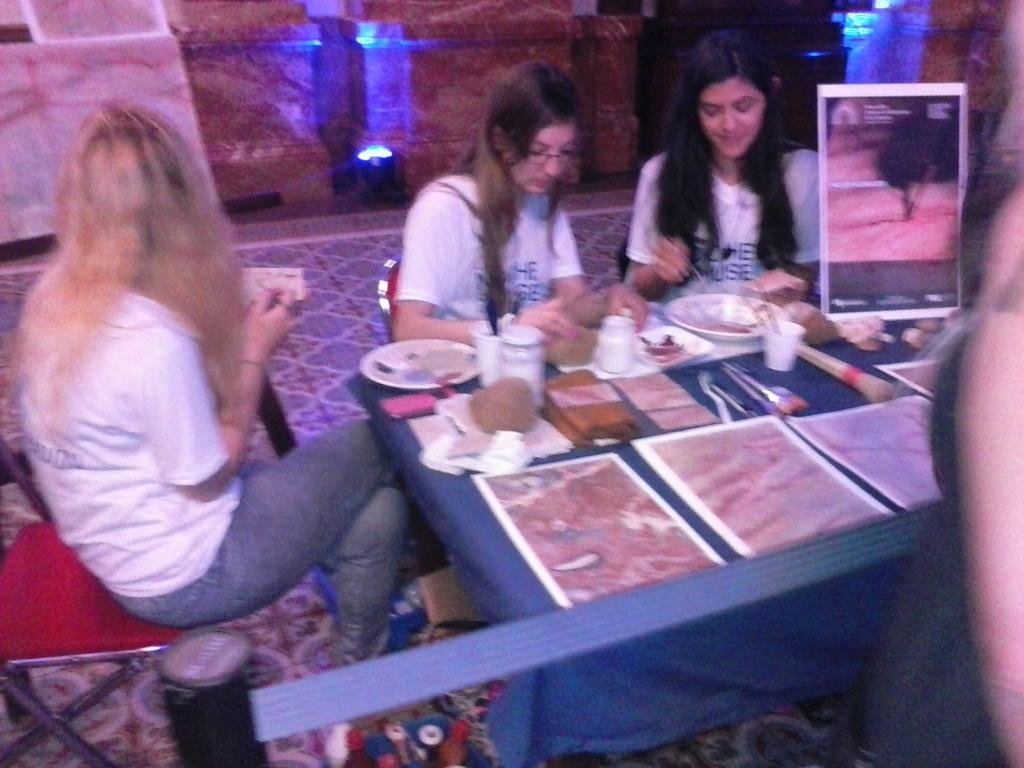How many women are in the image? There are three women in the image. What are the women doing in the image? The women are sitting in chairs. What is in front of the women? The women are in front of a table. What items can be seen on the table? There are cups, brushes, and bowls on the table. Are there any other items on the table? There may be other items on the table as well, but the provided facts do not specify what they are. What type of quilt is being used to cover the iron in the image? There is no quilt or iron present in the image; the women are sitting in chairs, and there is a table with cups, brushes, and bowls on it. 